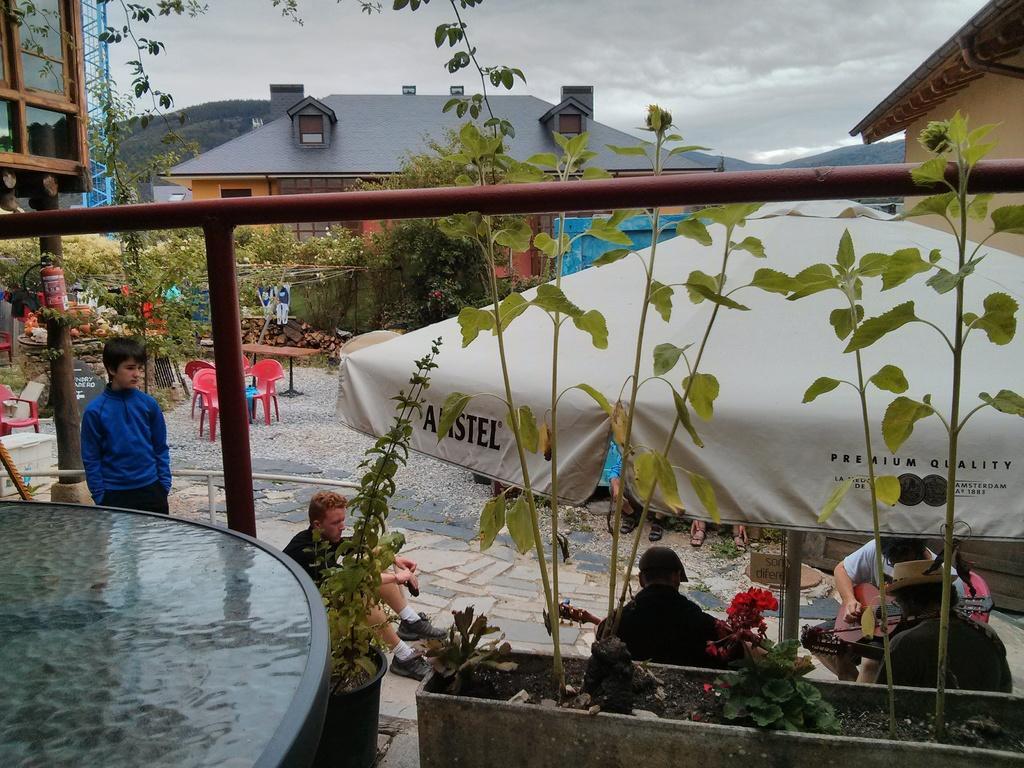Can you describe this image briefly? In the image in the center,we can see plant pots,plants,table and fence. In the background we can see the sky,clouds,buildings,trees,hills,plants,poles,sign boards,tents,chairs,banners,tables and few people were sitting and holding musical instruments. On the left side there is a person standing. 